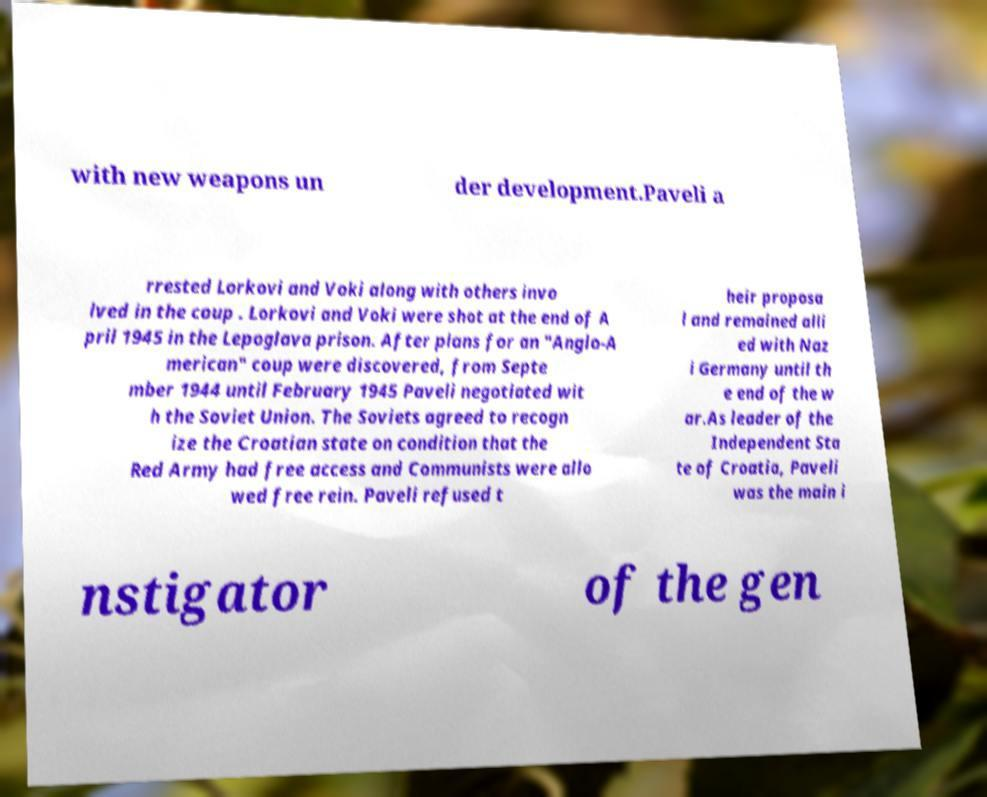Could you extract and type out the text from this image? with new weapons un der development.Paveli a rrested Lorkovi and Voki along with others invo lved in the coup . Lorkovi and Voki were shot at the end of A pril 1945 in the Lepoglava prison. After plans for an "Anglo-A merican" coup were discovered, from Septe mber 1944 until February 1945 Paveli negotiated wit h the Soviet Union. The Soviets agreed to recogn ize the Croatian state on condition that the Red Army had free access and Communists were allo wed free rein. Paveli refused t heir proposa l and remained alli ed with Naz i Germany until th e end of the w ar.As leader of the Independent Sta te of Croatia, Paveli was the main i nstigator of the gen 